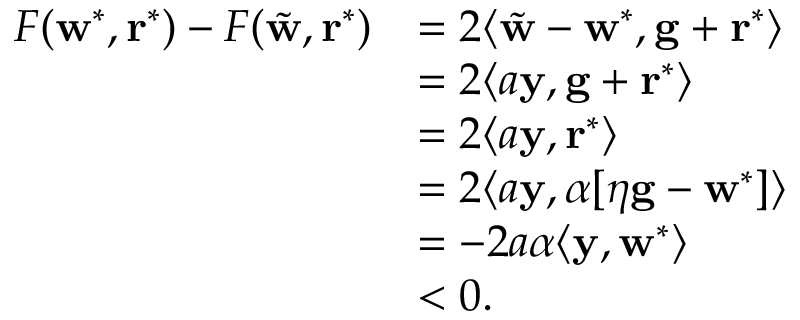<formula> <loc_0><loc_0><loc_500><loc_500>\begin{array} { r l } { F ( \mathbf w ^ { * } , \mathbf r ^ { * } ) - F ( \tilde { \mathbf w } , \mathbf r ^ { * } ) } & { = 2 \langle \tilde { \mathbf w } - \mathbf w ^ { * } , \mathbf g + \mathbf r ^ { * } \rangle } \\ & { = 2 \langle a \mathbf y , \mathbf g + \mathbf r ^ { * } \rangle } \\ & { = 2 \langle a \mathbf y , \mathbf r ^ { * } \rangle } \\ & { = 2 \langle a \mathbf y , \alpha [ \eta \mathbf g - \mathbf w ^ { * } ] \rangle } \\ & { = - 2 a \alpha \langle \mathbf y , \mathbf w ^ { * } \rangle } \\ & { < 0 . } \end{array}</formula> 